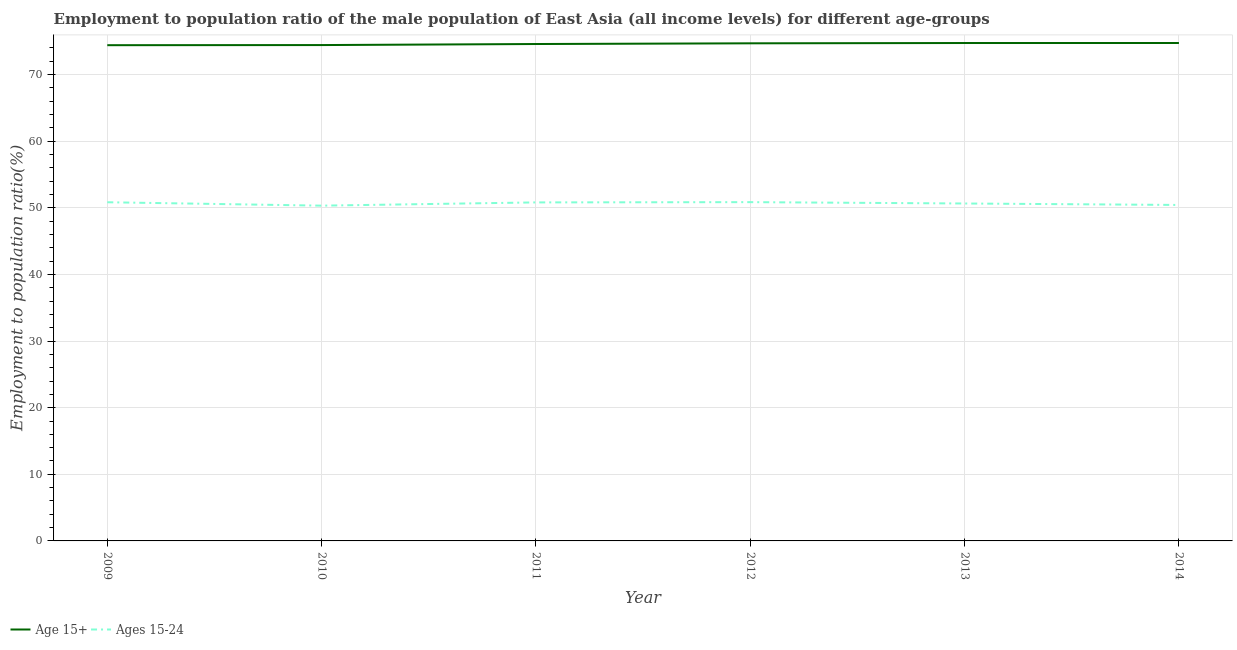Is the number of lines equal to the number of legend labels?
Give a very brief answer. Yes. What is the employment to population ratio(age 15-24) in 2011?
Provide a short and direct response. 50.81. Across all years, what is the maximum employment to population ratio(age 15-24)?
Provide a short and direct response. 50.85. Across all years, what is the minimum employment to population ratio(age 15-24)?
Offer a very short reply. 50.32. What is the total employment to population ratio(age 15-24) in the graph?
Your answer should be very brief. 303.9. What is the difference between the employment to population ratio(age 15-24) in 2009 and that in 2012?
Offer a very short reply. -0.02. What is the difference between the employment to population ratio(age 15-24) in 2014 and the employment to population ratio(age 15+) in 2010?
Provide a succinct answer. -24. What is the average employment to population ratio(age 15-24) per year?
Give a very brief answer. 50.65. In the year 2014, what is the difference between the employment to population ratio(age 15-24) and employment to population ratio(age 15+)?
Give a very brief answer. -24.31. In how many years, is the employment to population ratio(age 15+) greater than 36 %?
Provide a succinct answer. 6. What is the ratio of the employment to population ratio(age 15-24) in 2011 to that in 2013?
Keep it short and to the point. 1. Is the employment to population ratio(age 15+) in 2009 less than that in 2010?
Offer a very short reply. Yes. Is the difference between the employment to population ratio(age 15-24) in 2010 and 2013 greater than the difference between the employment to population ratio(age 15+) in 2010 and 2013?
Your response must be concise. No. What is the difference between the highest and the second highest employment to population ratio(age 15-24)?
Keep it short and to the point. 0.02. What is the difference between the highest and the lowest employment to population ratio(age 15-24)?
Your response must be concise. 0.53. Does the employment to population ratio(age 15+) monotonically increase over the years?
Your answer should be compact. Yes. Is the employment to population ratio(age 15-24) strictly less than the employment to population ratio(age 15+) over the years?
Keep it short and to the point. Yes. What is the difference between two consecutive major ticks on the Y-axis?
Provide a succinct answer. 10. What is the title of the graph?
Provide a succinct answer. Employment to population ratio of the male population of East Asia (all income levels) for different age-groups. What is the label or title of the X-axis?
Give a very brief answer. Year. What is the label or title of the Y-axis?
Provide a short and direct response. Employment to population ratio(%). What is the Employment to population ratio(%) in Age 15+ in 2009?
Keep it short and to the point. 74.41. What is the Employment to population ratio(%) in Ages 15-24 in 2009?
Provide a short and direct response. 50.83. What is the Employment to population ratio(%) of Age 15+ in 2010?
Give a very brief answer. 74.43. What is the Employment to population ratio(%) of Ages 15-24 in 2010?
Provide a short and direct response. 50.32. What is the Employment to population ratio(%) in Age 15+ in 2011?
Provide a succinct answer. 74.59. What is the Employment to population ratio(%) in Ages 15-24 in 2011?
Make the answer very short. 50.81. What is the Employment to population ratio(%) of Age 15+ in 2012?
Your answer should be compact. 74.69. What is the Employment to population ratio(%) in Ages 15-24 in 2012?
Ensure brevity in your answer.  50.85. What is the Employment to population ratio(%) in Age 15+ in 2013?
Provide a succinct answer. 74.74. What is the Employment to population ratio(%) of Ages 15-24 in 2013?
Give a very brief answer. 50.65. What is the Employment to population ratio(%) in Age 15+ in 2014?
Ensure brevity in your answer.  74.74. What is the Employment to population ratio(%) of Ages 15-24 in 2014?
Offer a very short reply. 50.43. Across all years, what is the maximum Employment to population ratio(%) of Age 15+?
Offer a very short reply. 74.74. Across all years, what is the maximum Employment to population ratio(%) of Ages 15-24?
Offer a terse response. 50.85. Across all years, what is the minimum Employment to population ratio(%) of Age 15+?
Make the answer very short. 74.41. Across all years, what is the minimum Employment to population ratio(%) of Ages 15-24?
Provide a succinct answer. 50.32. What is the total Employment to population ratio(%) of Age 15+ in the graph?
Make the answer very short. 447.58. What is the total Employment to population ratio(%) of Ages 15-24 in the graph?
Your answer should be compact. 303.9. What is the difference between the Employment to population ratio(%) in Age 15+ in 2009 and that in 2010?
Your answer should be compact. -0.02. What is the difference between the Employment to population ratio(%) in Ages 15-24 in 2009 and that in 2010?
Make the answer very short. 0.51. What is the difference between the Employment to population ratio(%) in Age 15+ in 2009 and that in 2011?
Offer a very short reply. -0.18. What is the difference between the Employment to population ratio(%) in Ages 15-24 in 2009 and that in 2011?
Offer a terse response. 0.02. What is the difference between the Employment to population ratio(%) of Age 15+ in 2009 and that in 2012?
Make the answer very short. -0.28. What is the difference between the Employment to population ratio(%) in Ages 15-24 in 2009 and that in 2012?
Your answer should be very brief. -0.02. What is the difference between the Employment to population ratio(%) of Age 15+ in 2009 and that in 2013?
Offer a very short reply. -0.33. What is the difference between the Employment to population ratio(%) of Ages 15-24 in 2009 and that in 2013?
Provide a succinct answer. 0.19. What is the difference between the Employment to population ratio(%) of Age 15+ in 2009 and that in 2014?
Make the answer very short. -0.33. What is the difference between the Employment to population ratio(%) of Ages 15-24 in 2009 and that in 2014?
Offer a very short reply. 0.41. What is the difference between the Employment to population ratio(%) in Age 15+ in 2010 and that in 2011?
Ensure brevity in your answer.  -0.16. What is the difference between the Employment to population ratio(%) in Ages 15-24 in 2010 and that in 2011?
Keep it short and to the point. -0.49. What is the difference between the Employment to population ratio(%) of Age 15+ in 2010 and that in 2012?
Your answer should be very brief. -0.26. What is the difference between the Employment to population ratio(%) of Ages 15-24 in 2010 and that in 2012?
Ensure brevity in your answer.  -0.53. What is the difference between the Employment to population ratio(%) in Age 15+ in 2010 and that in 2013?
Offer a very short reply. -0.31. What is the difference between the Employment to population ratio(%) in Ages 15-24 in 2010 and that in 2013?
Provide a short and direct response. -0.32. What is the difference between the Employment to population ratio(%) in Age 15+ in 2010 and that in 2014?
Keep it short and to the point. -0.31. What is the difference between the Employment to population ratio(%) of Ages 15-24 in 2010 and that in 2014?
Provide a succinct answer. -0.1. What is the difference between the Employment to population ratio(%) of Age 15+ in 2011 and that in 2012?
Ensure brevity in your answer.  -0.1. What is the difference between the Employment to population ratio(%) of Ages 15-24 in 2011 and that in 2012?
Offer a very short reply. -0.04. What is the difference between the Employment to population ratio(%) in Age 15+ in 2011 and that in 2013?
Ensure brevity in your answer.  -0.15. What is the difference between the Employment to population ratio(%) in Ages 15-24 in 2011 and that in 2013?
Keep it short and to the point. 0.16. What is the difference between the Employment to population ratio(%) of Age 15+ in 2011 and that in 2014?
Provide a short and direct response. -0.15. What is the difference between the Employment to population ratio(%) of Ages 15-24 in 2011 and that in 2014?
Ensure brevity in your answer.  0.38. What is the difference between the Employment to population ratio(%) of Age 15+ in 2012 and that in 2013?
Ensure brevity in your answer.  -0.05. What is the difference between the Employment to population ratio(%) in Ages 15-24 in 2012 and that in 2013?
Offer a very short reply. 0.2. What is the difference between the Employment to population ratio(%) of Age 15+ in 2012 and that in 2014?
Your response must be concise. -0.05. What is the difference between the Employment to population ratio(%) of Ages 15-24 in 2012 and that in 2014?
Your answer should be very brief. 0.42. What is the difference between the Employment to population ratio(%) in Age 15+ in 2013 and that in 2014?
Your response must be concise. -0. What is the difference between the Employment to population ratio(%) of Ages 15-24 in 2013 and that in 2014?
Provide a short and direct response. 0.22. What is the difference between the Employment to population ratio(%) of Age 15+ in 2009 and the Employment to population ratio(%) of Ages 15-24 in 2010?
Make the answer very short. 24.08. What is the difference between the Employment to population ratio(%) of Age 15+ in 2009 and the Employment to population ratio(%) of Ages 15-24 in 2011?
Make the answer very short. 23.6. What is the difference between the Employment to population ratio(%) in Age 15+ in 2009 and the Employment to population ratio(%) in Ages 15-24 in 2012?
Keep it short and to the point. 23.56. What is the difference between the Employment to population ratio(%) of Age 15+ in 2009 and the Employment to population ratio(%) of Ages 15-24 in 2013?
Your response must be concise. 23.76. What is the difference between the Employment to population ratio(%) of Age 15+ in 2009 and the Employment to population ratio(%) of Ages 15-24 in 2014?
Your response must be concise. 23.98. What is the difference between the Employment to population ratio(%) in Age 15+ in 2010 and the Employment to population ratio(%) in Ages 15-24 in 2011?
Your answer should be compact. 23.62. What is the difference between the Employment to population ratio(%) of Age 15+ in 2010 and the Employment to population ratio(%) of Ages 15-24 in 2012?
Your response must be concise. 23.58. What is the difference between the Employment to population ratio(%) of Age 15+ in 2010 and the Employment to population ratio(%) of Ages 15-24 in 2013?
Your response must be concise. 23.78. What is the difference between the Employment to population ratio(%) of Age 15+ in 2010 and the Employment to population ratio(%) of Ages 15-24 in 2014?
Your answer should be very brief. 24. What is the difference between the Employment to population ratio(%) in Age 15+ in 2011 and the Employment to population ratio(%) in Ages 15-24 in 2012?
Your answer should be very brief. 23.73. What is the difference between the Employment to population ratio(%) in Age 15+ in 2011 and the Employment to population ratio(%) in Ages 15-24 in 2013?
Offer a very short reply. 23.94. What is the difference between the Employment to population ratio(%) in Age 15+ in 2011 and the Employment to population ratio(%) in Ages 15-24 in 2014?
Provide a succinct answer. 24.16. What is the difference between the Employment to population ratio(%) in Age 15+ in 2012 and the Employment to population ratio(%) in Ages 15-24 in 2013?
Make the answer very short. 24.04. What is the difference between the Employment to population ratio(%) of Age 15+ in 2012 and the Employment to population ratio(%) of Ages 15-24 in 2014?
Ensure brevity in your answer.  24.26. What is the difference between the Employment to population ratio(%) of Age 15+ in 2013 and the Employment to population ratio(%) of Ages 15-24 in 2014?
Your response must be concise. 24.31. What is the average Employment to population ratio(%) in Age 15+ per year?
Your answer should be very brief. 74.6. What is the average Employment to population ratio(%) of Ages 15-24 per year?
Provide a short and direct response. 50.65. In the year 2009, what is the difference between the Employment to population ratio(%) in Age 15+ and Employment to population ratio(%) in Ages 15-24?
Offer a very short reply. 23.57. In the year 2010, what is the difference between the Employment to population ratio(%) in Age 15+ and Employment to population ratio(%) in Ages 15-24?
Your answer should be compact. 24.1. In the year 2011, what is the difference between the Employment to population ratio(%) in Age 15+ and Employment to population ratio(%) in Ages 15-24?
Your response must be concise. 23.77. In the year 2012, what is the difference between the Employment to population ratio(%) in Age 15+ and Employment to population ratio(%) in Ages 15-24?
Make the answer very short. 23.84. In the year 2013, what is the difference between the Employment to population ratio(%) of Age 15+ and Employment to population ratio(%) of Ages 15-24?
Your answer should be very brief. 24.09. In the year 2014, what is the difference between the Employment to population ratio(%) in Age 15+ and Employment to population ratio(%) in Ages 15-24?
Provide a short and direct response. 24.31. What is the ratio of the Employment to population ratio(%) in Age 15+ in 2009 to that in 2010?
Ensure brevity in your answer.  1. What is the ratio of the Employment to population ratio(%) of Age 15+ in 2009 to that in 2012?
Your answer should be very brief. 1. What is the ratio of the Employment to population ratio(%) in Ages 15-24 in 2009 to that in 2012?
Your response must be concise. 1. What is the ratio of the Employment to population ratio(%) in Age 15+ in 2009 to that in 2013?
Your response must be concise. 1. What is the ratio of the Employment to population ratio(%) in Ages 15-24 in 2009 to that in 2014?
Offer a terse response. 1.01. What is the ratio of the Employment to population ratio(%) of Ages 15-24 in 2010 to that in 2011?
Give a very brief answer. 0.99. What is the ratio of the Employment to population ratio(%) of Ages 15-24 in 2010 to that in 2012?
Offer a terse response. 0.99. What is the ratio of the Employment to population ratio(%) in Age 15+ in 2010 to that in 2013?
Keep it short and to the point. 1. What is the ratio of the Employment to population ratio(%) of Ages 15-24 in 2010 to that in 2013?
Your answer should be very brief. 0.99. What is the ratio of the Employment to population ratio(%) of Age 15+ in 2010 to that in 2014?
Your answer should be compact. 1. What is the ratio of the Employment to population ratio(%) of Ages 15-24 in 2010 to that in 2014?
Your response must be concise. 1. What is the ratio of the Employment to population ratio(%) in Ages 15-24 in 2011 to that in 2012?
Offer a terse response. 1. What is the ratio of the Employment to population ratio(%) of Age 15+ in 2011 to that in 2014?
Give a very brief answer. 1. What is the ratio of the Employment to population ratio(%) of Ages 15-24 in 2011 to that in 2014?
Give a very brief answer. 1.01. What is the ratio of the Employment to population ratio(%) in Age 15+ in 2012 to that in 2013?
Give a very brief answer. 1. What is the ratio of the Employment to population ratio(%) in Ages 15-24 in 2012 to that in 2013?
Offer a very short reply. 1. What is the ratio of the Employment to population ratio(%) of Age 15+ in 2012 to that in 2014?
Your answer should be compact. 1. What is the ratio of the Employment to population ratio(%) of Ages 15-24 in 2012 to that in 2014?
Your response must be concise. 1.01. What is the ratio of the Employment to population ratio(%) in Age 15+ in 2013 to that in 2014?
Make the answer very short. 1. What is the difference between the highest and the second highest Employment to population ratio(%) in Age 15+?
Provide a succinct answer. 0. What is the difference between the highest and the second highest Employment to population ratio(%) in Ages 15-24?
Provide a succinct answer. 0.02. What is the difference between the highest and the lowest Employment to population ratio(%) of Age 15+?
Provide a short and direct response. 0.33. What is the difference between the highest and the lowest Employment to population ratio(%) in Ages 15-24?
Your response must be concise. 0.53. 